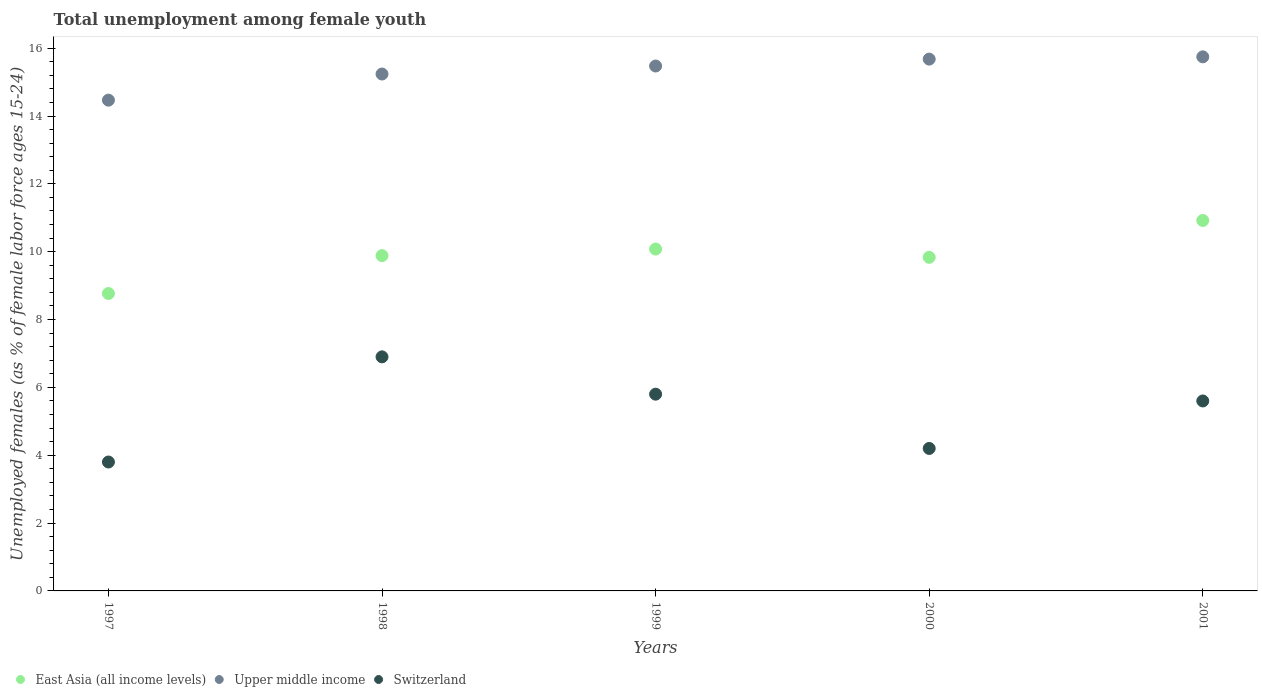How many different coloured dotlines are there?
Keep it short and to the point. 3. What is the percentage of unemployed females in in Switzerland in 1998?
Provide a short and direct response. 6.9. Across all years, what is the maximum percentage of unemployed females in in Switzerland?
Give a very brief answer. 6.9. Across all years, what is the minimum percentage of unemployed females in in Switzerland?
Provide a succinct answer. 3.8. What is the total percentage of unemployed females in in Upper middle income in the graph?
Offer a terse response. 76.6. What is the difference between the percentage of unemployed females in in Upper middle income in 2000 and that in 2001?
Ensure brevity in your answer.  -0.07. What is the difference between the percentage of unemployed females in in East Asia (all income levels) in 1999 and the percentage of unemployed females in in Switzerland in 2000?
Ensure brevity in your answer.  5.88. What is the average percentage of unemployed females in in Switzerland per year?
Offer a very short reply. 5.26. In the year 2001, what is the difference between the percentage of unemployed females in in East Asia (all income levels) and percentage of unemployed females in in Switzerland?
Give a very brief answer. 5.32. In how many years, is the percentage of unemployed females in in East Asia (all income levels) greater than 2.4 %?
Ensure brevity in your answer.  5. What is the ratio of the percentage of unemployed females in in Upper middle income in 1997 to that in 1998?
Provide a succinct answer. 0.95. Is the percentage of unemployed females in in Upper middle income in 1999 less than that in 2000?
Keep it short and to the point. Yes. What is the difference between the highest and the second highest percentage of unemployed females in in East Asia (all income levels)?
Ensure brevity in your answer.  0.84. What is the difference between the highest and the lowest percentage of unemployed females in in Upper middle income?
Your answer should be very brief. 1.28. In how many years, is the percentage of unemployed females in in Switzerland greater than the average percentage of unemployed females in in Switzerland taken over all years?
Your answer should be very brief. 3. Is it the case that in every year, the sum of the percentage of unemployed females in in Upper middle income and percentage of unemployed females in in Switzerland  is greater than the percentage of unemployed females in in East Asia (all income levels)?
Your answer should be compact. Yes. Does the percentage of unemployed females in in Upper middle income monotonically increase over the years?
Your response must be concise. Yes. Is the percentage of unemployed females in in Switzerland strictly greater than the percentage of unemployed females in in East Asia (all income levels) over the years?
Offer a terse response. No. What is the difference between two consecutive major ticks on the Y-axis?
Ensure brevity in your answer.  2. Does the graph contain any zero values?
Your response must be concise. No. Where does the legend appear in the graph?
Your response must be concise. Bottom left. How are the legend labels stacked?
Make the answer very short. Horizontal. What is the title of the graph?
Your answer should be compact. Total unemployment among female youth. What is the label or title of the Y-axis?
Offer a very short reply. Unemployed females (as % of female labor force ages 15-24). What is the Unemployed females (as % of female labor force ages 15-24) in East Asia (all income levels) in 1997?
Your response must be concise. 8.77. What is the Unemployed females (as % of female labor force ages 15-24) in Upper middle income in 1997?
Provide a short and direct response. 14.47. What is the Unemployed females (as % of female labor force ages 15-24) in Switzerland in 1997?
Give a very brief answer. 3.8. What is the Unemployed females (as % of female labor force ages 15-24) of East Asia (all income levels) in 1998?
Your response must be concise. 9.88. What is the Unemployed females (as % of female labor force ages 15-24) in Upper middle income in 1998?
Give a very brief answer. 15.24. What is the Unemployed females (as % of female labor force ages 15-24) in Switzerland in 1998?
Offer a very short reply. 6.9. What is the Unemployed females (as % of female labor force ages 15-24) of East Asia (all income levels) in 1999?
Your answer should be very brief. 10.08. What is the Unemployed females (as % of female labor force ages 15-24) in Upper middle income in 1999?
Your answer should be compact. 15.47. What is the Unemployed females (as % of female labor force ages 15-24) in Switzerland in 1999?
Make the answer very short. 5.8. What is the Unemployed females (as % of female labor force ages 15-24) of East Asia (all income levels) in 2000?
Make the answer very short. 9.83. What is the Unemployed females (as % of female labor force ages 15-24) of Upper middle income in 2000?
Ensure brevity in your answer.  15.68. What is the Unemployed females (as % of female labor force ages 15-24) of Switzerland in 2000?
Provide a short and direct response. 4.2. What is the Unemployed females (as % of female labor force ages 15-24) in East Asia (all income levels) in 2001?
Make the answer very short. 10.92. What is the Unemployed females (as % of female labor force ages 15-24) in Upper middle income in 2001?
Ensure brevity in your answer.  15.74. What is the Unemployed females (as % of female labor force ages 15-24) of Switzerland in 2001?
Provide a short and direct response. 5.6. Across all years, what is the maximum Unemployed females (as % of female labor force ages 15-24) of East Asia (all income levels)?
Keep it short and to the point. 10.92. Across all years, what is the maximum Unemployed females (as % of female labor force ages 15-24) of Upper middle income?
Ensure brevity in your answer.  15.74. Across all years, what is the maximum Unemployed females (as % of female labor force ages 15-24) of Switzerland?
Give a very brief answer. 6.9. Across all years, what is the minimum Unemployed females (as % of female labor force ages 15-24) of East Asia (all income levels)?
Provide a short and direct response. 8.77. Across all years, what is the minimum Unemployed females (as % of female labor force ages 15-24) in Upper middle income?
Your answer should be compact. 14.47. Across all years, what is the minimum Unemployed females (as % of female labor force ages 15-24) of Switzerland?
Make the answer very short. 3.8. What is the total Unemployed females (as % of female labor force ages 15-24) of East Asia (all income levels) in the graph?
Ensure brevity in your answer.  49.49. What is the total Unemployed females (as % of female labor force ages 15-24) of Upper middle income in the graph?
Make the answer very short. 76.6. What is the total Unemployed females (as % of female labor force ages 15-24) in Switzerland in the graph?
Give a very brief answer. 26.3. What is the difference between the Unemployed females (as % of female labor force ages 15-24) in East Asia (all income levels) in 1997 and that in 1998?
Provide a short and direct response. -1.12. What is the difference between the Unemployed females (as % of female labor force ages 15-24) of Upper middle income in 1997 and that in 1998?
Give a very brief answer. -0.77. What is the difference between the Unemployed females (as % of female labor force ages 15-24) of East Asia (all income levels) in 1997 and that in 1999?
Your answer should be compact. -1.31. What is the difference between the Unemployed females (as % of female labor force ages 15-24) of Upper middle income in 1997 and that in 1999?
Provide a succinct answer. -1.01. What is the difference between the Unemployed females (as % of female labor force ages 15-24) in Switzerland in 1997 and that in 1999?
Your answer should be very brief. -2. What is the difference between the Unemployed females (as % of female labor force ages 15-24) of East Asia (all income levels) in 1997 and that in 2000?
Keep it short and to the point. -1.07. What is the difference between the Unemployed females (as % of female labor force ages 15-24) of Upper middle income in 1997 and that in 2000?
Provide a succinct answer. -1.21. What is the difference between the Unemployed females (as % of female labor force ages 15-24) of Switzerland in 1997 and that in 2000?
Provide a short and direct response. -0.4. What is the difference between the Unemployed females (as % of female labor force ages 15-24) of East Asia (all income levels) in 1997 and that in 2001?
Offer a very short reply. -2.15. What is the difference between the Unemployed females (as % of female labor force ages 15-24) of Upper middle income in 1997 and that in 2001?
Your answer should be very brief. -1.28. What is the difference between the Unemployed females (as % of female labor force ages 15-24) of Switzerland in 1997 and that in 2001?
Your answer should be compact. -1.8. What is the difference between the Unemployed females (as % of female labor force ages 15-24) of East Asia (all income levels) in 1998 and that in 1999?
Ensure brevity in your answer.  -0.19. What is the difference between the Unemployed females (as % of female labor force ages 15-24) of Upper middle income in 1998 and that in 1999?
Your answer should be compact. -0.24. What is the difference between the Unemployed females (as % of female labor force ages 15-24) in Switzerland in 1998 and that in 1999?
Ensure brevity in your answer.  1.1. What is the difference between the Unemployed females (as % of female labor force ages 15-24) in East Asia (all income levels) in 1998 and that in 2000?
Give a very brief answer. 0.05. What is the difference between the Unemployed females (as % of female labor force ages 15-24) of Upper middle income in 1998 and that in 2000?
Provide a succinct answer. -0.44. What is the difference between the Unemployed females (as % of female labor force ages 15-24) of East Asia (all income levels) in 1998 and that in 2001?
Give a very brief answer. -1.04. What is the difference between the Unemployed females (as % of female labor force ages 15-24) of Upper middle income in 1998 and that in 2001?
Your answer should be very brief. -0.51. What is the difference between the Unemployed females (as % of female labor force ages 15-24) in Switzerland in 1998 and that in 2001?
Your answer should be very brief. 1.3. What is the difference between the Unemployed females (as % of female labor force ages 15-24) of East Asia (all income levels) in 1999 and that in 2000?
Your answer should be very brief. 0.24. What is the difference between the Unemployed females (as % of female labor force ages 15-24) in Upper middle income in 1999 and that in 2000?
Your answer should be compact. -0.2. What is the difference between the Unemployed females (as % of female labor force ages 15-24) in East Asia (all income levels) in 1999 and that in 2001?
Keep it short and to the point. -0.84. What is the difference between the Unemployed females (as % of female labor force ages 15-24) in Upper middle income in 1999 and that in 2001?
Offer a very short reply. -0.27. What is the difference between the Unemployed females (as % of female labor force ages 15-24) of East Asia (all income levels) in 2000 and that in 2001?
Ensure brevity in your answer.  -1.09. What is the difference between the Unemployed females (as % of female labor force ages 15-24) in Upper middle income in 2000 and that in 2001?
Ensure brevity in your answer.  -0.07. What is the difference between the Unemployed females (as % of female labor force ages 15-24) of East Asia (all income levels) in 1997 and the Unemployed females (as % of female labor force ages 15-24) of Upper middle income in 1998?
Provide a succinct answer. -6.47. What is the difference between the Unemployed females (as % of female labor force ages 15-24) in East Asia (all income levels) in 1997 and the Unemployed females (as % of female labor force ages 15-24) in Switzerland in 1998?
Give a very brief answer. 1.87. What is the difference between the Unemployed females (as % of female labor force ages 15-24) of Upper middle income in 1997 and the Unemployed females (as % of female labor force ages 15-24) of Switzerland in 1998?
Your answer should be very brief. 7.57. What is the difference between the Unemployed females (as % of female labor force ages 15-24) of East Asia (all income levels) in 1997 and the Unemployed females (as % of female labor force ages 15-24) of Upper middle income in 1999?
Provide a short and direct response. -6.71. What is the difference between the Unemployed females (as % of female labor force ages 15-24) of East Asia (all income levels) in 1997 and the Unemployed females (as % of female labor force ages 15-24) of Switzerland in 1999?
Provide a short and direct response. 2.97. What is the difference between the Unemployed females (as % of female labor force ages 15-24) of Upper middle income in 1997 and the Unemployed females (as % of female labor force ages 15-24) of Switzerland in 1999?
Your response must be concise. 8.67. What is the difference between the Unemployed females (as % of female labor force ages 15-24) of East Asia (all income levels) in 1997 and the Unemployed females (as % of female labor force ages 15-24) of Upper middle income in 2000?
Ensure brevity in your answer.  -6.91. What is the difference between the Unemployed females (as % of female labor force ages 15-24) of East Asia (all income levels) in 1997 and the Unemployed females (as % of female labor force ages 15-24) of Switzerland in 2000?
Ensure brevity in your answer.  4.57. What is the difference between the Unemployed females (as % of female labor force ages 15-24) in Upper middle income in 1997 and the Unemployed females (as % of female labor force ages 15-24) in Switzerland in 2000?
Make the answer very short. 10.27. What is the difference between the Unemployed females (as % of female labor force ages 15-24) in East Asia (all income levels) in 1997 and the Unemployed females (as % of female labor force ages 15-24) in Upper middle income in 2001?
Make the answer very short. -6.98. What is the difference between the Unemployed females (as % of female labor force ages 15-24) of East Asia (all income levels) in 1997 and the Unemployed females (as % of female labor force ages 15-24) of Switzerland in 2001?
Ensure brevity in your answer.  3.17. What is the difference between the Unemployed females (as % of female labor force ages 15-24) in Upper middle income in 1997 and the Unemployed females (as % of female labor force ages 15-24) in Switzerland in 2001?
Offer a very short reply. 8.87. What is the difference between the Unemployed females (as % of female labor force ages 15-24) of East Asia (all income levels) in 1998 and the Unemployed females (as % of female labor force ages 15-24) of Upper middle income in 1999?
Offer a terse response. -5.59. What is the difference between the Unemployed females (as % of female labor force ages 15-24) of East Asia (all income levels) in 1998 and the Unemployed females (as % of female labor force ages 15-24) of Switzerland in 1999?
Ensure brevity in your answer.  4.08. What is the difference between the Unemployed females (as % of female labor force ages 15-24) of Upper middle income in 1998 and the Unemployed females (as % of female labor force ages 15-24) of Switzerland in 1999?
Provide a short and direct response. 9.44. What is the difference between the Unemployed females (as % of female labor force ages 15-24) of East Asia (all income levels) in 1998 and the Unemployed females (as % of female labor force ages 15-24) of Upper middle income in 2000?
Offer a very short reply. -5.79. What is the difference between the Unemployed females (as % of female labor force ages 15-24) of East Asia (all income levels) in 1998 and the Unemployed females (as % of female labor force ages 15-24) of Switzerland in 2000?
Keep it short and to the point. 5.68. What is the difference between the Unemployed females (as % of female labor force ages 15-24) in Upper middle income in 1998 and the Unemployed females (as % of female labor force ages 15-24) in Switzerland in 2000?
Keep it short and to the point. 11.04. What is the difference between the Unemployed females (as % of female labor force ages 15-24) of East Asia (all income levels) in 1998 and the Unemployed females (as % of female labor force ages 15-24) of Upper middle income in 2001?
Your response must be concise. -5.86. What is the difference between the Unemployed females (as % of female labor force ages 15-24) in East Asia (all income levels) in 1998 and the Unemployed females (as % of female labor force ages 15-24) in Switzerland in 2001?
Your answer should be very brief. 4.28. What is the difference between the Unemployed females (as % of female labor force ages 15-24) in Upper middle income in 1998 and the Unemployed females (as % of female labor force ages 15-24) in Switzerland in 2001?
Provide a succinct answer. 9.64. What is the difference between the Unemployed females (as % of female labor force ages 15-24) of East Asia (all income levels) in 1999 and the Unemployed females (as % of female labor force ages 15-24) of Upper middle income in 2000?
Keep it short and to the point. -5.6. What is the difference between the Unemployed females (as % of female labor force ages 15-24) of East Asia (all income levels) in 1999 and the Unemployed females (as % of female labor force ages 15-24) of Switzerland in 2000?
Your answer should be compact. 5.88. What is the difference between the Unemployed females (as % of female labor force ages 15-24) in Upper middle income in 1999 and the Unemployed females (as % of female labor force ages 15-24) in Switzerland in 2000?
Ensure brevity in your answer.  11.27. What is the difference between the Unemployed females (as % of female labor force ages 15-24) of East Asia (all income levels) in 1999 and the Unemployed females (as % of female labor force ages 15-24) of Upper middle income in 2001?
Provide a succinct answer. -5.67. What is the difference between the Unemployed females (as % of female labor force ages 15-24) of East Asia (all income levels) in 1999 and the Unemployed females (as % of female labor force ages 15-24) of Switzerland in 2001?
Make the answer very short. 4.48. What is the difference between the Unemployed females (as % of female labor force ages 15-24) in Upper middle income in 1999 and the Unemployed females (as % of female labor force ages 15-24) in Switzerland in 2001?
Make the answer very short. 9.87. What is the difference between the Unemployed females (as % of female labor force ages 15-24) in East Asia (all income levels) in 2000 and the Unemployed females (as % of female labor force ages 15-24) in Upper middle income in 2001?
Ensure brevity in your answer.  -5.91. What is the difference between the Unemployed females (as % of female labor force ages 15-24) of East Asia (all income levels) in 2000 and the Unemployed females (as % of female labor force ages 15-24) of Switzerland in 2001?
Give a very brief answer. 4.23. What is the difference between the Unemployed females (as % of female labor force ages 15-24) in Upper middle income in 2000 and the Unemployed females (as % of female labor force ages 15-24) in Switzerland in 2001?
Keep it short and to the point. 10.08. What is the average Unemployed females (as % of female labor force ages 15-24) in East Asia (all income levels) per year?
Provide a succinct answer. 9.9. What is the average Unemployed females (as % of female labor force ages 15-24) in Upper middle income per year?
Make the answer very short. 15.32. What is the average Unemployed females (as % of female labor force ages 15-24) of Switzerland per year?
Your answer should be very brief. 5.26. In the year 1997, what is the difference between the Unemployed females (as % of female labor force ages 15-24) of East Asia (all income levels) and Unemployed females (as % of female labor force ages 15-24) of Upper middle income?
Keep it short and to the point. -5.7. In the year 1997, what is the difference between the Unemployed females (as % of female labor force ages 15-24) of East Asia (all income levels) and Unemployed females (as % of female labor force ages 15-24) of Switzerland?
Provide a succinct answer. 4.97. In the year 1997, what is the difference between the Unemployed females (as % of female labor force ages 15-24) in Upper middle income and Unemployed females (as % of female labor force ages 15-24) in Switzerland?
Provide a short and direct response. 10.67. In the year 1998, what is the difference between the Unemployed females (as % of female labor force ages 15-24) in East Asia (all income levels) and Unemployed females (as % of female labor force ages 15-24) in Upper middle income?
Provide a succinct answer. -5.35. In the year 1998, what is the difference between the Unemployed females (as % of female labor force ages 15-24) in East Asia (all income levels) and Unemployed females (as % of female labor force ages 15-24) in Switzerland?
Offer a terse response. 2.98. In the year 1998, what is the difference between the Unemployed females (as % of female labor force ages 15-24) in Upper middle income and Unemployed females (as % of female labor force ages 15-24) in Switzerland?
Your response must be concise. 8.34. In the year 1999, what is the difference between the Unemployed females (as % of female labor force ages 15-24) of East Asia (all income levels) and Unemployed females (as % of female labor force ages 15-24) of Upper middle income?
Offer a terse response. -5.4. In the year 1999, what is the difference between the Unemployed females (as % of female labor force ages 15-24) of East Asia (all income levels) and Unemployed females (as % of female labor force ages 15-24) of Switzerland?
Give a very brief answer. 4.28. In the year 1999, what is the difference between the Unemployed females (as % of female labor force ages 15-24) in Upper middle income and Unemployed females (as % of female labor force ages 15-24) in Switzerland?
Make the answer very short. 9.67. In the year 2000, what is the difference between the Unemployed females (as % of female labor force ages 15-24) in East Asia (all income levels) and Unemployed females (as % of female labor force ages 15-24) in Upper middle income?
Your response must be concise. -5.84. In the year 2000, what is the difference between the Unemployed females (as % of female labor force ages 15-24) of East Asia (all income levels) and Unemployed females (as % of female labor force ages 15-24) of Switzerland?
Your answer should be compact. 5.63. In the year 2000, what is the difference between the Unemployed females (as % of female labor force ages 15-24) in Upper middle income and Unemployed females (as % of female labor force ages 15-24) in Switzerland?
Keep it short and to the point. 11.48. In the year 2001, what is the difference between the Unemployed females (as % of female labor force ages 15-24) in East Asia (all income levels) and Unemployed females (as % of female labor force ages 15-24) in Upper middle income?
Offer a very short reply. -4.82. In the year 2001, what is the difference between the Unemployed females (as % of female labor force ages 15-24) in East Asia (all income levels) and Unemployed females (as % of female labor force ages 15-24) in Switzerland?
Ensure brevity in your answer.  5.32. In the year 2001, what is the difference between the Unemployed females (as % of female labor force ages 15-24) of Upper middle income and Unemployed females (as % of female labor force ages 15-24) of Switzerland?
Give a very brief answer. 10.14. What is the ratio of the Unemployed females (as % of female labor force ages 15-24) in East Asia (all income levels) in 1997 to that in 1998?
Your answer should be compact. 0.89. What is the ratio of the Unemployed females (as % of female labor force ages 15-24) in Upper middle income in 1997 to that in 1998?
Offer a very short reply. 0.95. What is the ratio of the Unemployed females (as % of female labor force ages 15-24) of Switzerland in 1997 to that in 1998?
Offer a terse response. 0.55. What is the ratio of the Unemployed females (as % of female labor force ages 15-24) of East Asia (all income levels) in 1997 to that in 1999?
Provide a short and direct response. 0.87. What is the ratio of the Unemployed females (as % of female labor force ages 15-24) in Upper middle income in 1997 to that in 1999?
Your response must be concise. 0.94. What is the ratio of the Unemployed females (as % of female labor force ages 15-24) in Switzerland in 1997 to that in 1999?
Your answer should be compact. 0.66. What is the ratio of the Unemployed females (as % of female labor force ages 15-24) of East Asia (all income levels) in 1997 to that in 2000?
Give a very brief answer. 0.89. What is the ratio of the Unemployed females (as % of female labor force ages 15-24) in Upper middle income in 1997 to that in 2000?
Your answer should be compact. 0.92. What is the ratio of the Unemployed females (as % of female labor force ages 15-24) in Switzerland in 1997 to that in 2000?
Your answer should be compact. 0.9. What is the ratio of the Unemployed females (as % of female labor force ages 15-24) in East Asia (all income levels) in 1997 to that in 2001?
Provide a short and direct response. 0.8. What is the ratio of the Unemployed females (as % of female labor force ages 15-24) of Upper middle income in 1997 to that in 2001?
Keep it short and to the point. 0.92. What is the ratio of the Unemployed females (as % of female labor force ages 15-24) in Switzerland in 1997 to that in 2001?
Keep it short and to the point. 0.68. What is the ratio of the Unemployed females (as % of female labor force ages 15-24) in East Asia (all income levels) in 1998 to that in 1999?
Your answer should be compact. 0.98. What is the ratio of the Unemployed females (as % of female labor force ages 15-24) of Upper middle income in 1998 to that in 1999?
Give a very brief answer. 0.98. What is the ratio of the Unemployed females (as % of female labor force ages 15-24) of Switzerland in 1998 to that in 1999?
Your answer should be compact. 1.19. What is the ratio of the Unemployed females (as % of female labor force ages 15-24) of Switzerland in 1998 to that in 2000?
Provide a short and direct response. 1.64. What is the ratio of the Unemployed females (as % of female labor force ages 15-24) of East Asia (all income levels) in 1998 to that in 2001?
Your answer should be compact. 0.91. What is the ratio of the Unemployed females (as % of female labor force ages 15-24) in Upper middle income in 1998 to that in 2001?
Your answer should be very brief. 0.97. What is the ratio of the Unemployed females (as % of female labor force ages 15-24) of Switzerland in 1998 to that in 2001?
Ensure brevity in your answer.  1.23. What is the ratio of the Unemployed females (as % of female labor force ages 15-24) in East Asia (all income levels) in 1999 to that in 2000?
Ensure brevity in your answer.  1.02. What is the ratio of the Unemployed females (as % of female labor force ages 15-24) of Upper middle income in 1999 to that in 2000?
Ensure brevity in your answer.  0.99. What is the ratio of the Unemployed females (as % of female labor force ages 15-24) of Switzerland in 1999 to that in 2000?
Provide a short and direct response. 1.38. What is the ratio of the Unemployed females (as % of female labor force ages 15-24) in East Asia (all income levels) in 1999 to that in 2001?
Make the answer very short. 0.92. What is the ratio of the Unemployed females (as % of female labor force ages 15-24) in Upper middle income in 1999 to that in 2001?
Your response must be concise. 0.98. What is the ratio of the Unemployed females (as % of female labor force ages 15-24) in Switzerland in 1999 to that in 2001?
Ensure brevity in your answer.  1.04. What is the ratio of the Unemployed females (as % of female labor force ages 15-24) of East Asia (all income levels) in 2000 to that in 2001?
Offer a very short reply. 0.9. What is the difference between the highest and the second highest Unemployed females (as % of female labor force ages 15-24) in East Asia (all income levels)?
Ensure brevity in your answer.  0.84. What is the difference between the highest and the second highest Unemployed females (as % of female labor force ages 15-24) of Upper middle income?
Offer a very short reply. 0.07. What is the difference between the highest and the lowest Unemployed females (as % of female labor force ages 15-24) in East Asia (all income levels)?
Your answer should be compact. 2.15. What is the difference between the highest and the lowest Unemployed females (as % of female labor force ages 15-24) in Upper middle income?
Keep it short and to the point. 1.28. What is the difference between the highest and the lowest Unemployed females (as % of female labor force ages 15-24) of Switzerland?
Make the answer very short. 3.1. 